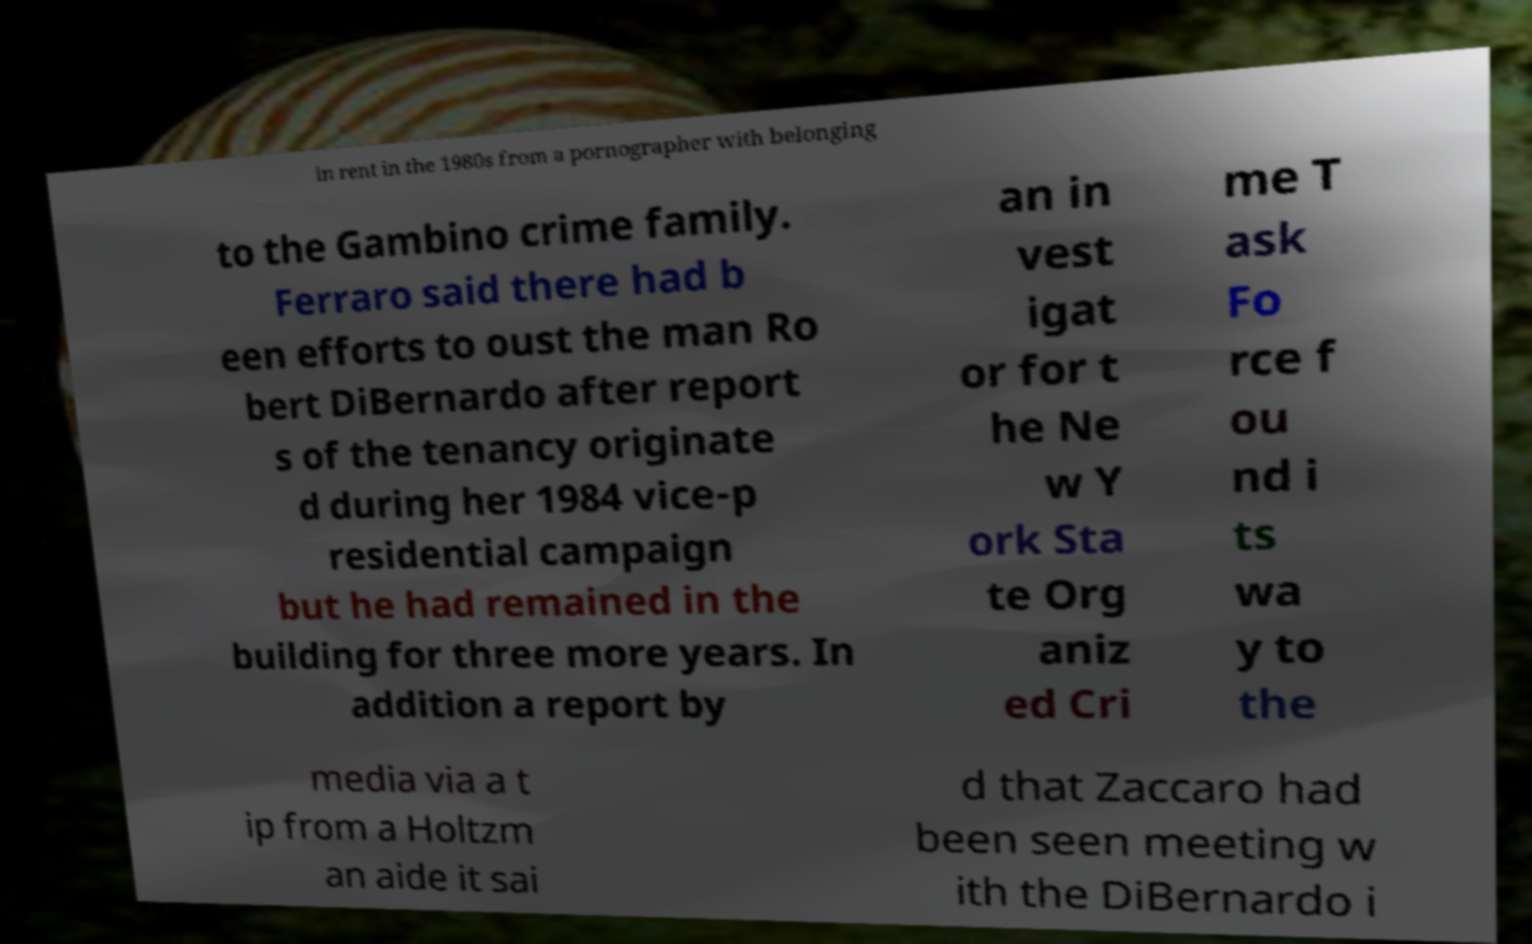Please read and relay the text visible in this image. What does it say? in rent in the 1980s from a pornographer with belonging to the Gambino crime family. Ferraro said there had b een efforts to oust the man Ro bert DiBernardo after report s of the tenancy originate d during her 1984 vice-p residential campaign but he had remained in the building for three more years. In addition a report by an in vest igat or for t he Ne w Y ork Sta te Org aniz ed Cri me T ask Fo rce f ou nd i ts wa y to the media via a t ip from a Holtzm an aide it sai d that Zaccaro had been seen meeting w ith the DiBernardo i 